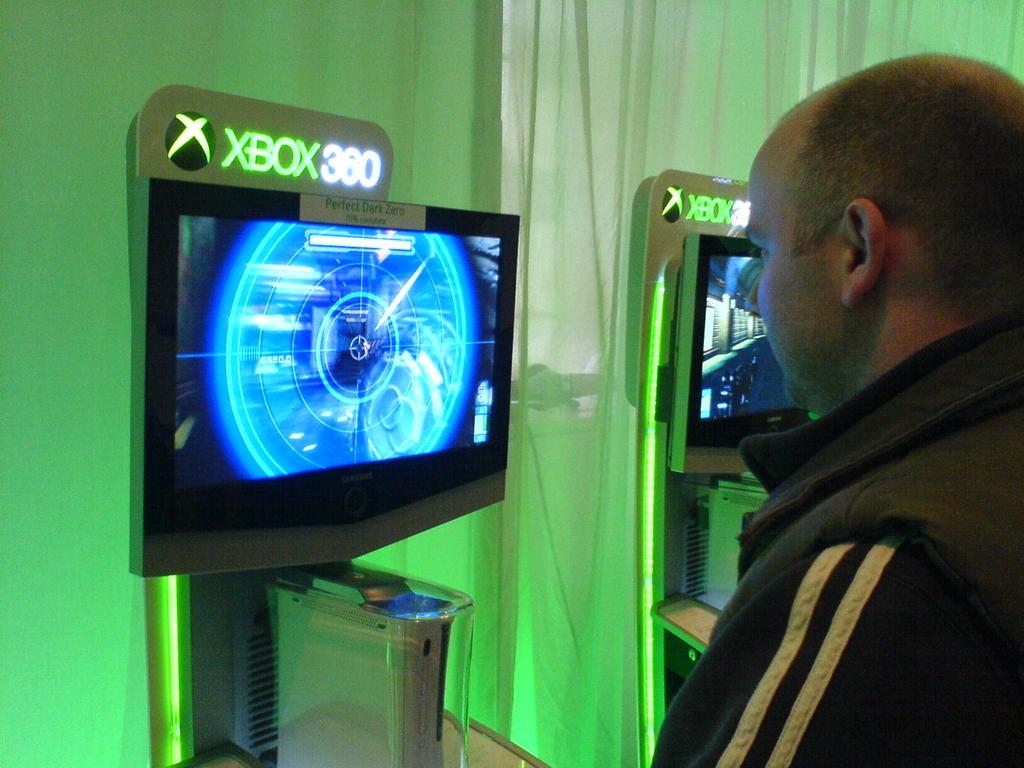What game is he playing?
Ensure brevity in your answer.  Perfect dark zero. Is that an xbox game?
Ensure brevity in your answer.  Yes. 